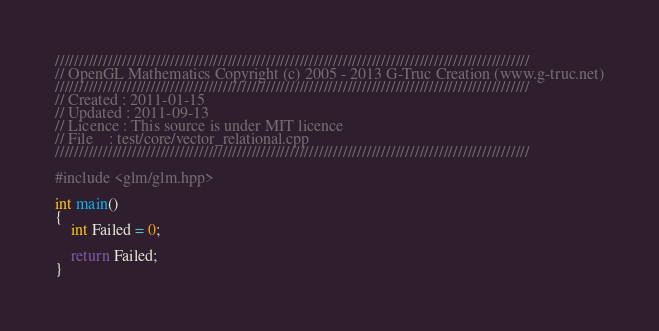<code> <loc_0><loc_0><loc_500><loc_500><_C++_>///////////////////////////////////////////////////////////////////////////////////////////////////
// OpenGL Mathematics Copyright (c) 2005 - 2013 G-Truc Creation (www.g-truc.net)
///////////////////////////////////////////////////////////////////////////////////////////////////
// Created : 2011-01-15
// Updated : 2011-09-13
// Licence : This source is under MIT licence
// File    : test/core/vector_relational.cpp
///////////////////////////////////////////////////////////////////////////////////////////////////

#include <glm/glm.hpp>

int main()
{
	int Failed = 0;

	return Failed;
}

</code> 